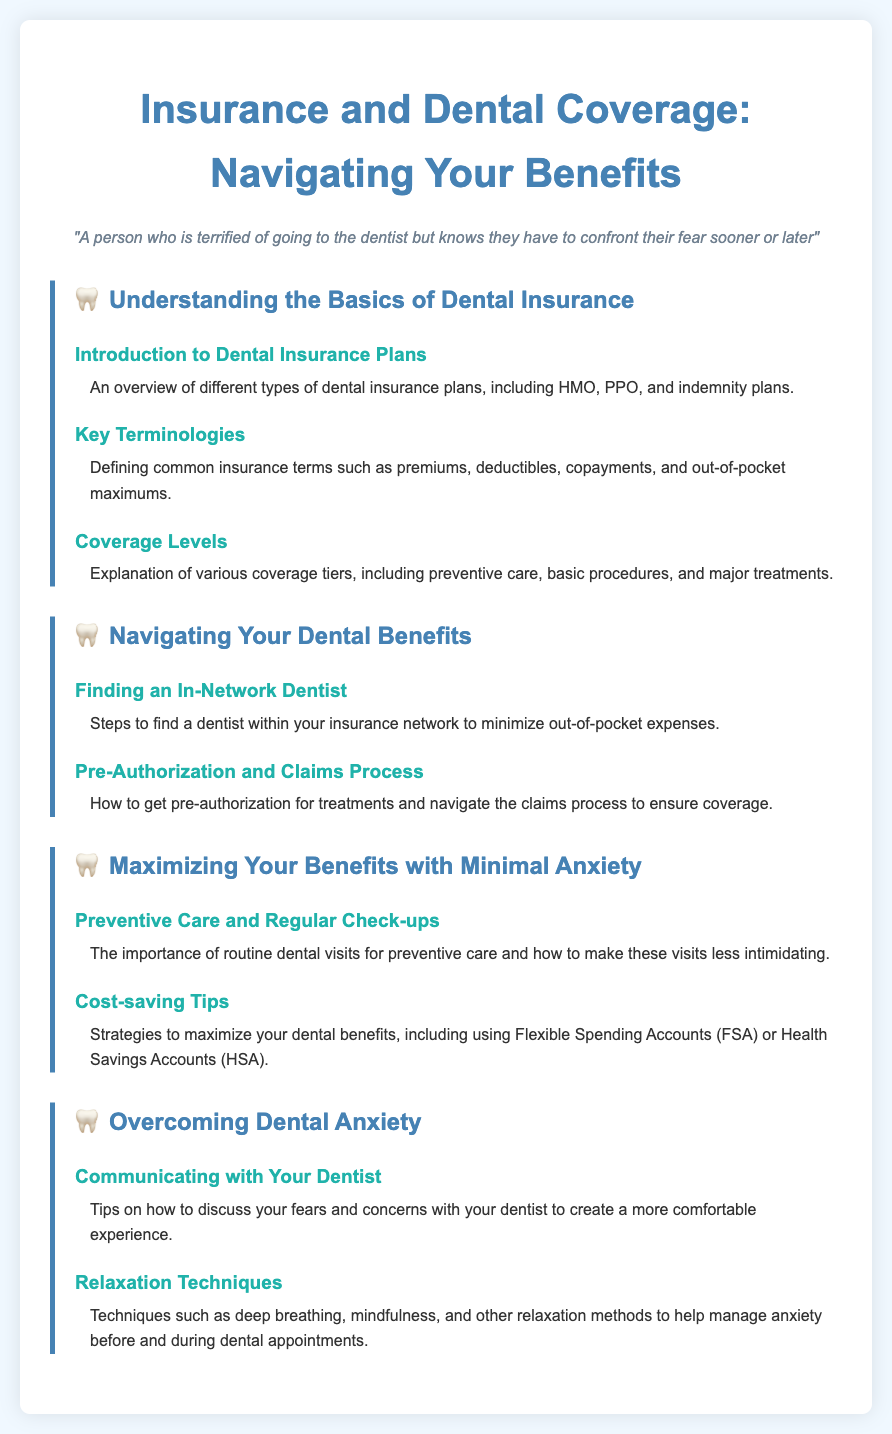what is the title of the syllabus? The title of the syllabus is prominently displayed at the top of the document.
Answer: Insurance and Dental Coverage: Navigating Your Benefits what is the focus of the first module? The first module provides foundational knowledge about dental insurance to help navigate benefits.
Answer: Understanding the Basics of Dental Insurance how many types of dental insurance plans are introduced? The document highlights different types of dental insurance plans in the first topic of the first module.
Answer: Three what is one key term defined in the syllabus? The syllabus includes a section specifically for defining insurance terminologies in the second topic.
Answer: Premiums what is the purpose of finding an in-network dentist? The purpose is explained in the second module related to minimizing out-of-pocket expenses for dental care.
Answer: Minimize out-of-pocket expenses which technique is suggested for managing anxiety before dental appointments? The document suggests relaxation techniques that can help manage dental anxiety, specifically in the fourth module.
Answer: Deep breathing what is one cost-saving strategy mentioned in the syllabus? The syllabus includes a section on cost-saving tips in the third module, which discusses maximizing benefits.
Answer: Flexible Spending Accounts (FSA) how many topics are covered in the module about overcoming dental anxiety? The module regarding overcoming dental anxiety consists of two specific topics addressing this issue.
Answer: Two 